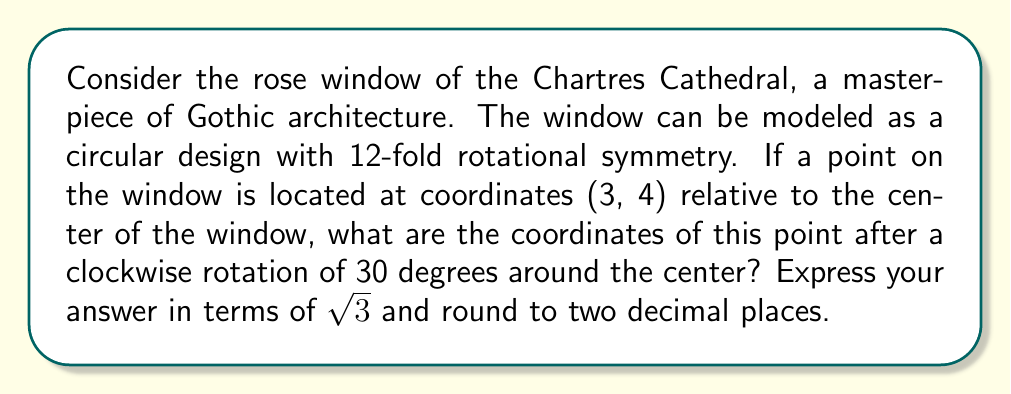Can you answer this question? To solve this problem, we'll use the rotation matrix for a clockwise rotation of $\theta$ degrees:

$$
R_\theta = \begin{bmatrix}
\cos\theta & \sin\theta \\
-\sin\theta & \cos\theta
\end{bmatrix}
$$

For a 30-degree rotation, $\theta = 30°$. We know that:

$\cos 30° = \frac{\sqrt{3}}{2}$ and $\sin 30° = \frac{1}{2}$

Therefore, our rotation matrix becomes:

$$
R_{30°} = \begin{bmatrix}
\frac{\sqrt{3}}{2} & \frac{1}{2} \\
-\frac{1}{2} & \frac{\sqrt{3}}{2}
\end{bmatrix}
$$

To find the new coordinates $(x', y')$, we multiply this matrix by the original coordinates:

$$
\begin{bmatrix}
x' \\
y'
\end{bmatrix} = 
\begin{bmatrix}
\frac{\sqrt{3}}{2} & \frac{1}{2} \\
-\frac{1}{2} & \frac{\sqrt{3}}{2}
\end{bmatrix}
\begin{bmatrix}
3 \\
4
\end{bmatrix}
$$

Calculating:

$$
x' = \frac{\sqrt{3}}{2}(3) + \frac{1}{2}(4) = \frac{3\sqrt{3}}{2} + 2
$$

$$
y' = -\frac{1}{2}(3) + \frac{\sqrt{3}}{2}(4) = -\frac{3}{2} + 2\sqrt{3}
$$

Simplifying and rounding to two decimal places:

$x' \approx 4.60$
$y' \approx 1.96$
Answer: (4.60, 1.96) 